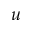Convert formula to latex. <formula><loc_0><loc_0><loc_500><loc_500>u</formula> 